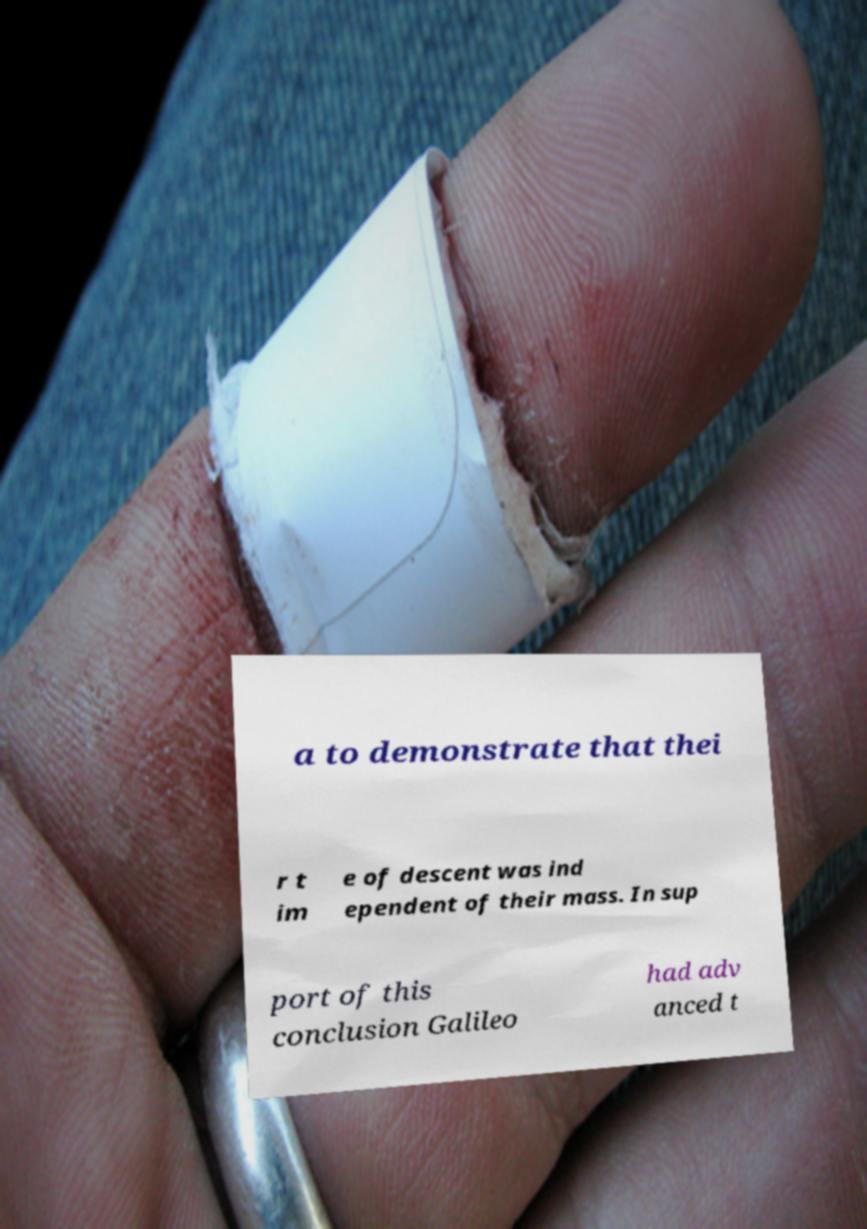Can you accurately transcribe the text from the provided image for me? a to demonstrate that thei r t im e of descent was ind ependent of their mass. In sup port of this conclusion Galileo had adv anced t 